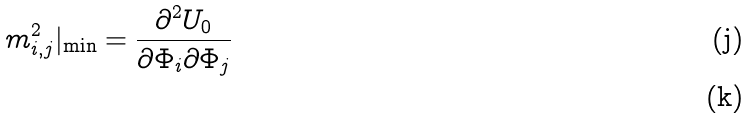<formula> <loc_0><loc_0><loc_500><loc_500>m ^ { 2 } _ { i , j } | _ { \min } = \frac { \partial ^ { 2 } U _ { 0 } } { \partial \Phi _ { i } \partial \Phi _ { j } } \\</formula> 